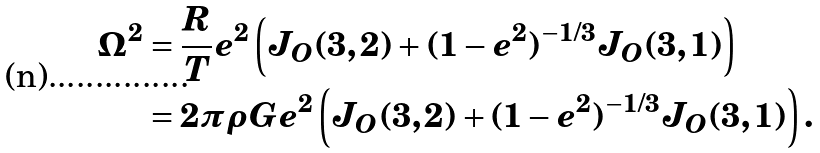<formula> <loc_0><loc_0><loc_500><loc_500>\Omega ^ { 2 } & = \frac { R } { T } e ^ { 2 } \left ( J _ { O } ( 3 , 2 ) + ( 1 - e ^ { 2 } ) ^ { - 1 / 3 } J _ { O } ( 3 , 1 ) \right ) \\ & = 2 \pi \rho G e ^ { 2 } \left ( J _ { O } ( 3 , 2 ) + ( 1 - e ^ { 2 } ) ^ { - 1 / 3 } J _ { O } ( 3 , 1 ) \right ) .</formula> 